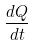<formula> <loc_0><loc_0><loc_500><loc_500>\frac { d Q } { d t }</formula> 